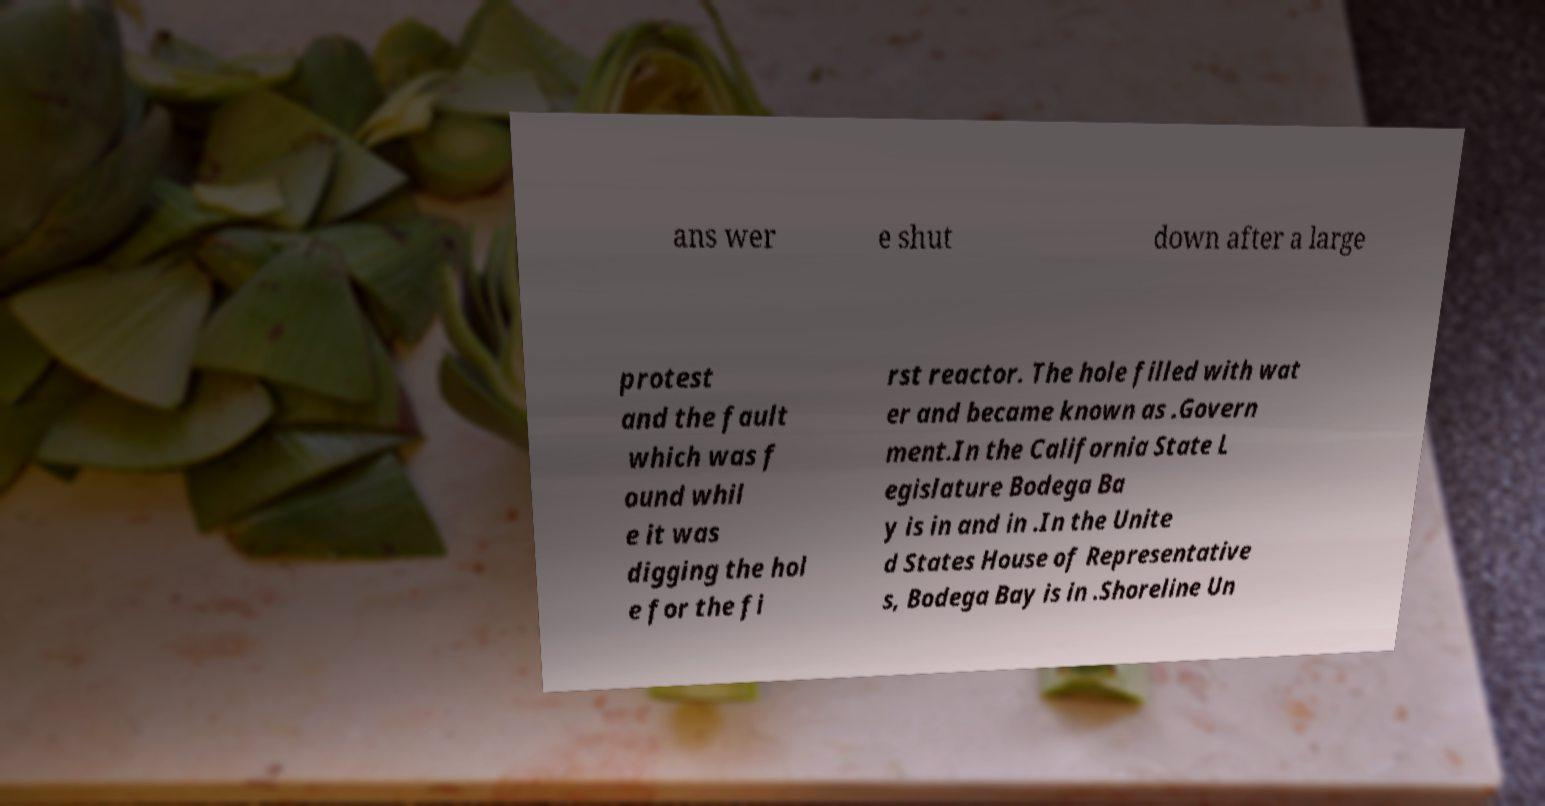I need the written content from this picture converted into text. Can you do that? ans wer e shut down after a large protest and the fault which was f ound whil e it was digging the hol e for the fi rst reactor. The hole filled with wat er and became known as .Govern ment.In the California State L egislature Bodega Ba y is in and in .In the Unite d States House of Representative s, Bodega Bay is in .Shoreline Un 